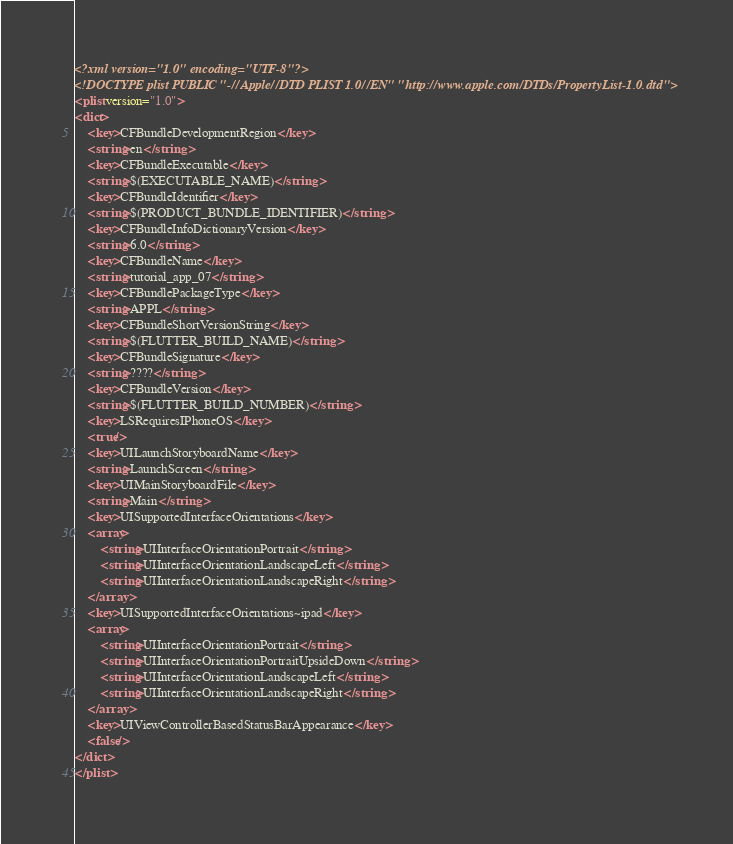<code> <loc_0><loc_0><loc_500><loc_500><_XML_><?xml version="1.0" encoding="UTF-8"?>
<!DOCTYPE plist PUBLIC "-//Apple//DTD PLIST 1.0//EN" "http://www.apple.com/DTDs/PropertyList-1.0.dtd">
<plist version="1.0">
<dict>
	<key>CFBundleDevelopmentRegion</key>
	<string>en</string>
	<key>CFBundleExecutable</key>
	<string>$(EXECUTABLE_NAME)</string>
	<key>CFBundleIdentifier</key>
	<string>$(PRODUCT_BUNDLE_IDENTIFIER)</string>
	<key>CFBundleInfoDictionaryVersion</key>
	<string>6.0</string>
	<key>CFBundleName</key>
	<string>tutorial_app_07</string>
	<key>CFBundlePackageType</key>
	<string>APPL</string>
	<key>CFBundleShortVersionString</key>
	<string>$(FLUTTER_BUILD_NAME)</string>
	<key>CFBundleSignature</key>
	<string>????</string>
	<key>CFBundleVersion</key>
	<string>$(FLUTTER_BUILD_NUMBER)</string>
	<key>LSRequiresIPhoneOS</key>
	<true/>
	<key>UILaunchStoryboardName</key>
	<string>LaunchScreen</string>
	<key>UIMainStoryboardFile</key>
	<string>Main</string>
	<key>UISupportedInterfaceOrientations</key>
	<array>
		<string>UIInterfaceOrientationPortrait</string>
		<string>UIInterfaceOrientationLandscapeLeft</string>
		<string>UIInterfaceOrientationLandscapeRight</string>
	</array>
	<key>UISupportedInterfaceOrientations~ipad</key>
	<array>
		<string>UIInterfaceOrientationPortrait</string>
		<string>UIInterfaceOrientationPortraitUpsideDown</string>
		<string>UIInterfaceOrientationLandscapeLeft</string>
		<string>UIInterfaceOrientationLandscapeRight</string>
	</array>
	<key>UIViewControllerBasedStatusBarAppearance</key>
	<false/>
</dict>
</plist>
</code> 